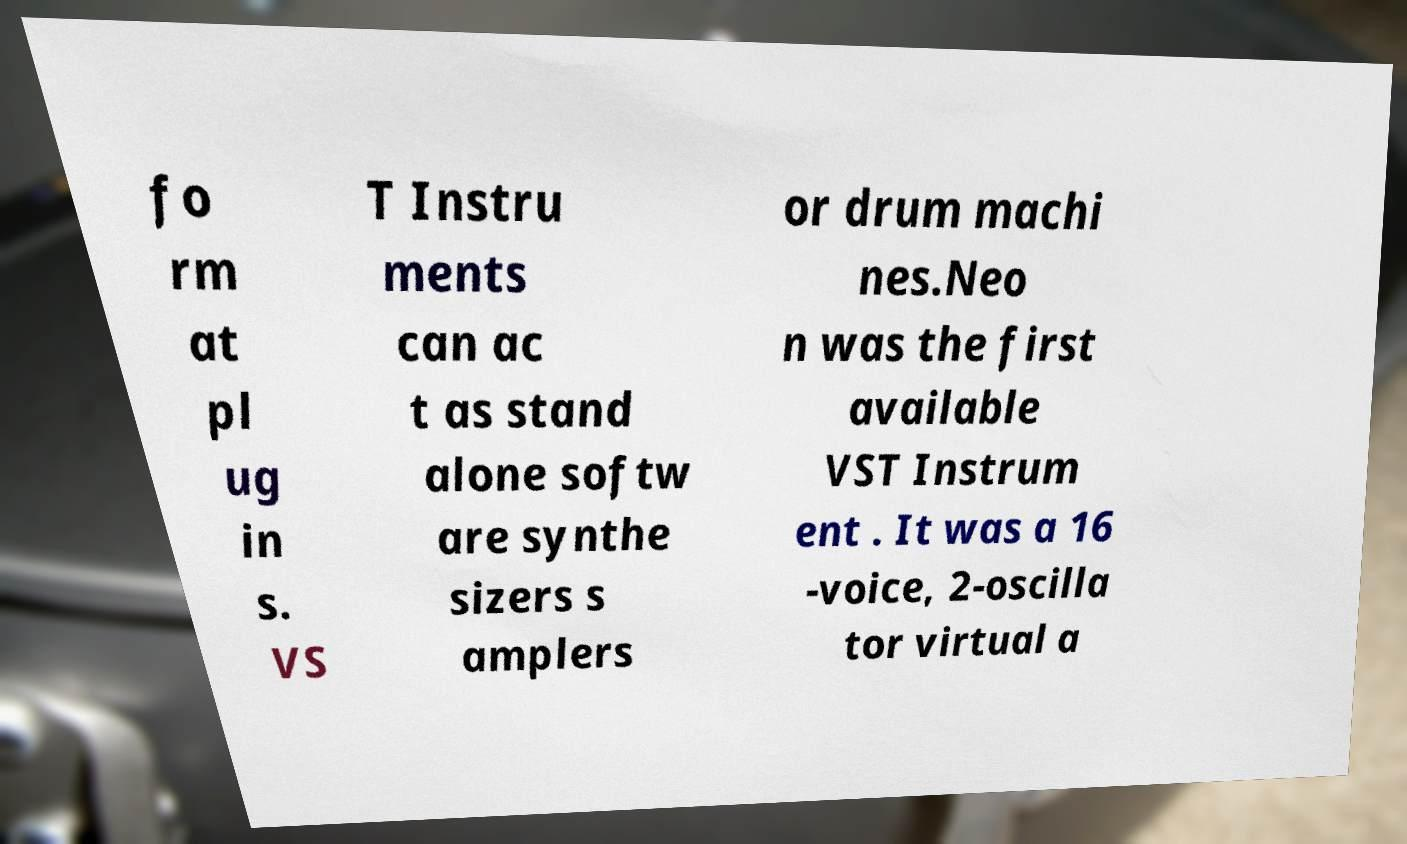I need the written content from this picture converted into text. Can you do that? fo rm at pl ug in s. VS T Instru ments can ac t as stand alone softw are synthe sizers s amplers or drum machi nes.Neo n was the first available VST Instrum ent . It was a 16 -voice, 2-oscilla tor virtual a 